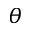Convert formula to latex. <formula><loc_0><loc_0><loc_500><loc_500>\theta</formula> 